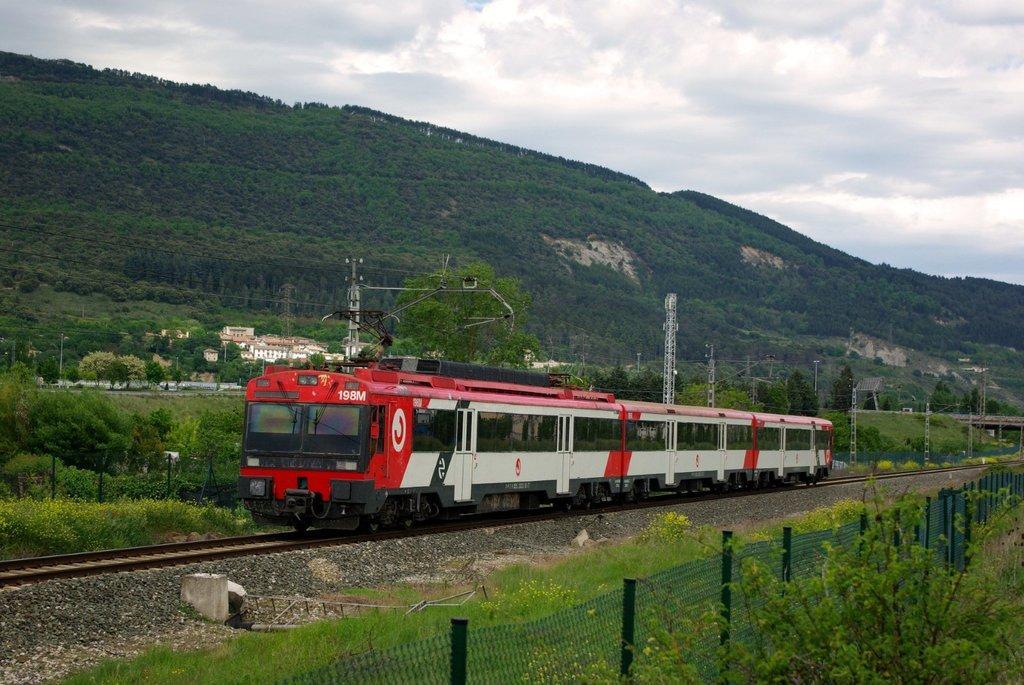How would you summarize this image in a sentence or two? A train is present on a railway track. There is a fencing. There are trees, transformers, buildings and hills. 